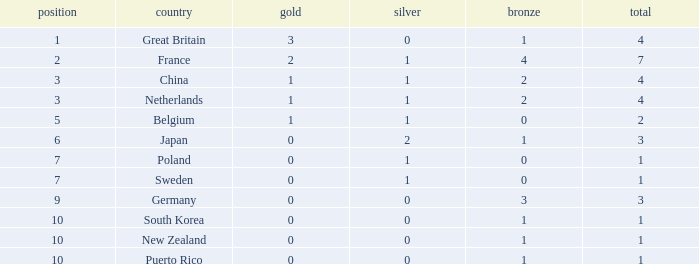What is the rank with 0 bronze? None. Help me parse the entirety of this table. {'header': ['position', 'country', 'gold', 'silver', 'bronze', 'total'], 'rows': [['1', 'Great Britain', '3', '0', '1', '4'], ['2', 'France', '2', '1', '4', '7'], ['3', 'China', '1', '1', '2', '4'], ['3', 'Netherlands', '1', '1', '2', '4'], ['5', 'Belgium', '1', '1', '0', '2'], ['6', 'Japan', '0', '2', '1', '3'], ['7', 'Poland', '0', '1', '0', '1'], ['7', 'Sweden', '0', '1', '0', '1'], ['9', 'Germany', '0', '0', '3', '3'], ['10', 'South Korea', '0', '0', '1', '1'], ['10', 'New Zealand', '0', '0', '1', '1'], ['10', 'Puerto Rico', '0', '0', '1', '1']]} 